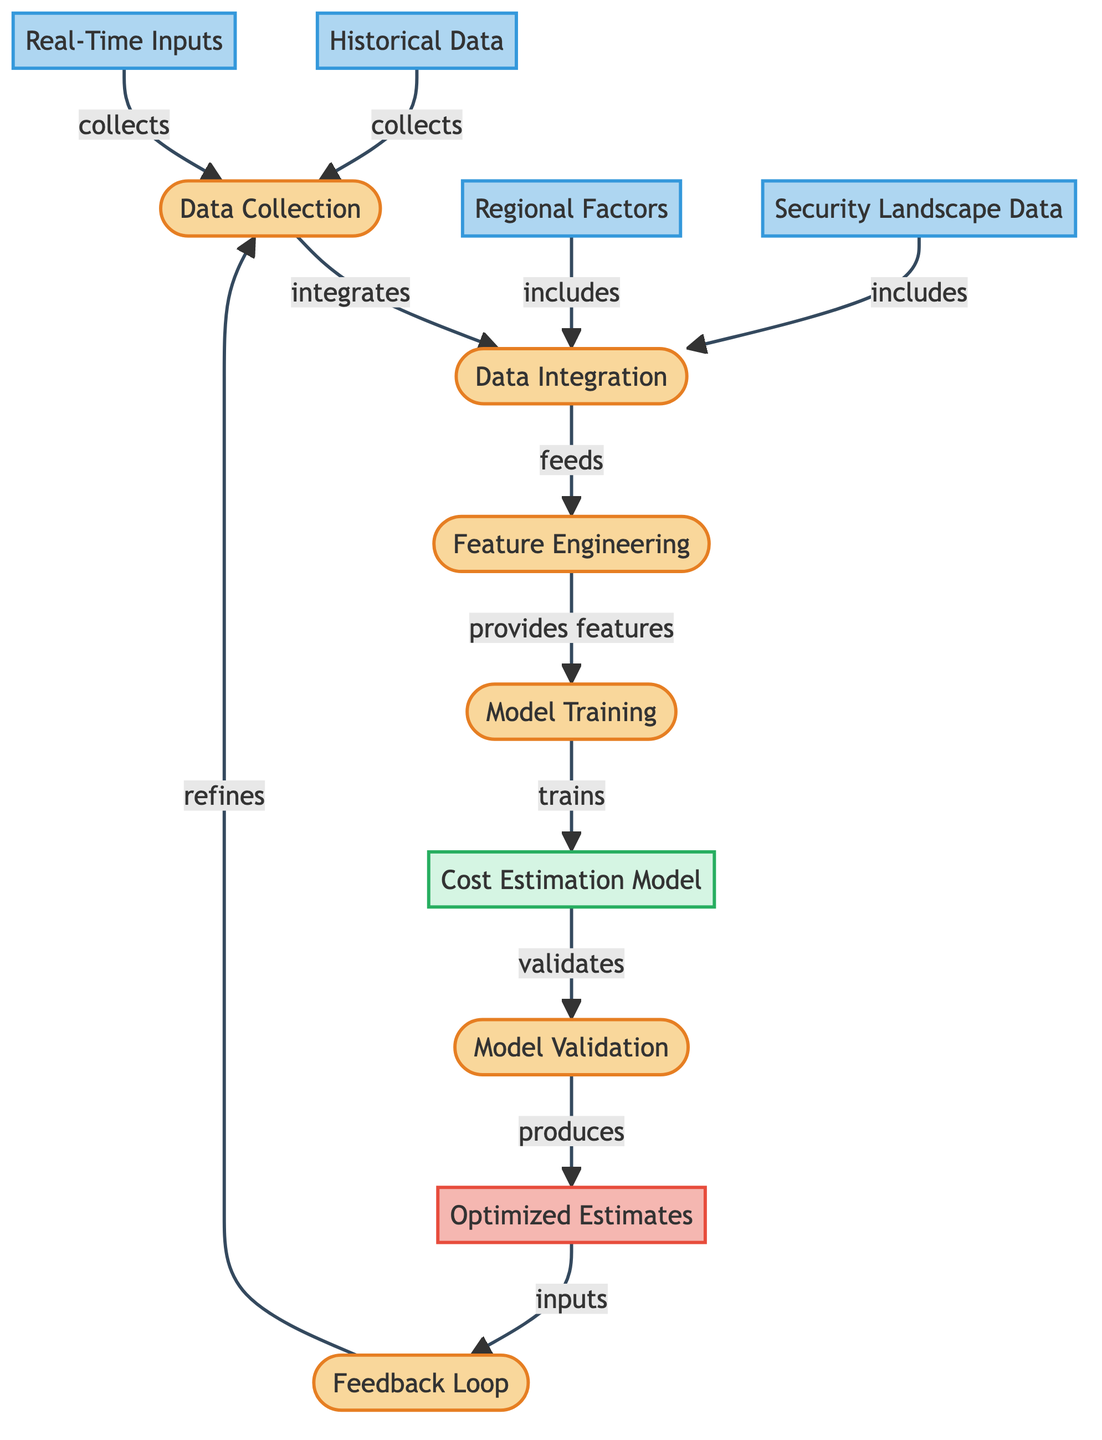What are the inputs for data collection? The inputs for data collection are historical data and real-time inputs, as shown by the direct connections from those nodes to the data collection node.
Answer: historical data, real-time inputs What follows data integration in the diagram? After data integration, the next process is feature engineering, as indicated by the arrow leading from the data integration node to the feature engineering node.
Answer: feature engineering How many data nodes are in the diagram? The diagram contains four data nodes: historical data, real-time inputs, regional factors, and security landscape data, which can be counted directly from the diagram's data sections.
Answer: four Which process involves the cost estimation model? The cost estimation model is involved in the model training process, indicating that the model is trained there before moving to the subsequent steps such as model validation.
Answer: model training What does the feedback loop refine? The feedback loop refines the data collection process, as shown by the arrow from the feedback loop pointing back to the data collection node.
Answer: data collection What relationship exists between security landscape data and data integration? The security landscape data is included in the data integration process, meaning that it is considered as part of the integration workflow for building projects.
Answer: includes How many processes are there from data collection to optimized estimates? There are four processes leading from data collection through to optimized estimates: data integration, feature engineering, model training, and model validation.
Answer: four What is produced after model validation? The model validation process produces optimized estimates, as indicated by the direct flow from the model validation node to the optimized estimates node.
Answer: optimized estimates 